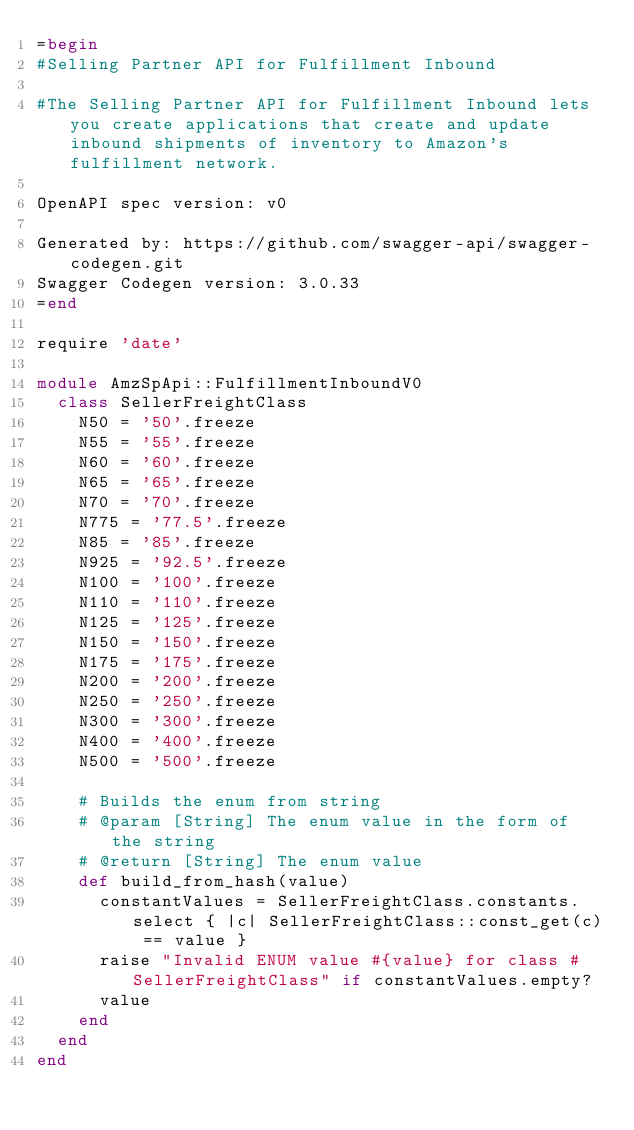<code> <loc_0><loc_0><loc_500><loc_500><_Ruby_>=begin
#Selling Partner API for Fulfillment Inbound

#The Selling Partner API for Fulfillment Inbound lets you create applications that create and update inbound shipments of inventory to Amazon's fulfillment network.

OpenAPI spec version: v0

Generated by: https://github.com/swagger-api/swagger-codegen.git
Swagger Codegen version: 3.0.33
=end

require 'date'

module AmzSpApi::FulfillmentInboundV0
  class SellerFreightClass
    N50 = '50'.freeze
    N55 = '55'.freeze
    N60 = '60'.freeze
    N65 = '65'.freeze
    N70 = '70'.freeze
    N775 = '77.5'.freeze
    N85 = '85'.freeze
    N925 = '92.5'.freeze
    N100 = '100'.freeze
    N110 = '110'.freeze
    N125 = '125'.freeze
    N150 = '150'.freeze
    N175 = '175'.freeze
    N200 = '200'.freeze
    N250 = '250'.freeze
    N300 = '300'.freeze
    N400 = '400'.freeze
    N500 = '500'.freeze

    # Builds the enum from string
    # @param [String] The enum value in the form of the string
    # @return [String] The enum value
    def build_from_hash(value)
      constantValues = SellerFreightClass.constants.select { |c| SellerFreightClass::const_get(c) == value }
      raise "Invalid ENUM value #{value} for class #SellerFreightClass" if constantValues.empty?
      value
    end
  end
end
</code> 